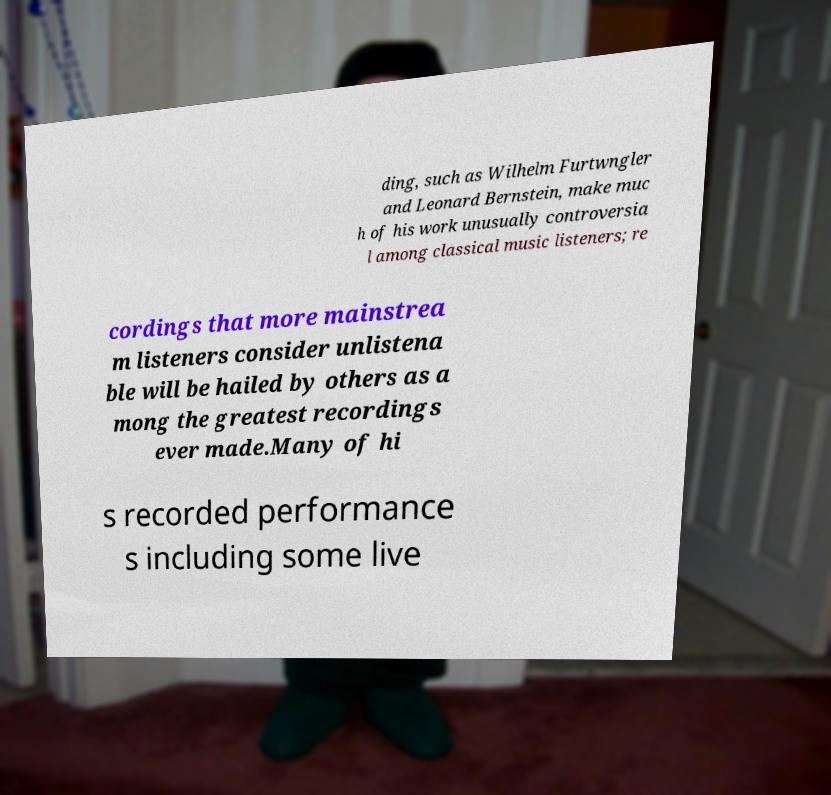Could you assist in decoding the text presented in this image and type it out clearly? ding, such as Wilhelm Furtwngler and Leonard Bernstein, make muc h of his work unusually controversia l among classical music listeners; re cordings that more mainstrea m listeners consider unlistena ble will be hailed by others as a mong the greatest recordings ever made.Many of hi s recorded performance s including some live 